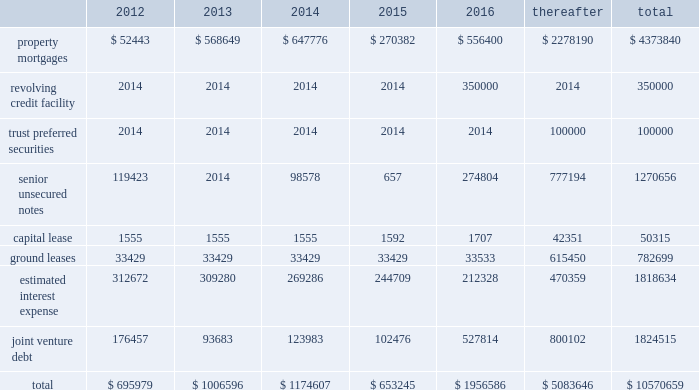56 / 57 management 2019s discussion and analysis of financial condition and results of operations junior subordinate deferrable interest debentures in june 2005 , we issued $ 100.0 a0million of trust preferred securities , which are reflected on the balance sheet as junior subordinate deferrable interest debentures .
The proceeds were used to repay our revolving credit facility .
The $ 100.0 a0million of junior subordi- nate deferrable interest debentures have a 30-year term ending july 2035 .
They bear interest at a fixed rate of 5.61% ( 5.61 % ) for the first 10 years ending july 2015 .
Thereafter , the rate will float at three month libor plus 1.25% ( 1.25 % ) .
The securities are redeemable at par .
Restrictive covenants the terms of the 2011 revolving credit facility and certain of our senior unsecured notes include certain restrictions and covenants which may limit , among other things , our ability to pay dividends ( as discussed below ) , make certain types of investments , incur additional indebtedness , incur liens and enter into negative pledge agreements and the disposition of assets , and which require compliance with financial ratios including our minimum tangible net worth , a maximum ratio of total indebtedness to total asset value , a minimum ratio of ebitda to fixed charges and a maximum ratio of unsecured indebtedness to unencumbered asset value .
The dividend restriction referred to above provides that we will not during any time when we are in default , make distributions with respect to common stock or other equity interests , except to enable us to continue to qualify as a reit for federal income tax purposes .
As of december a031 , 2011 and 2010 , we were in compli- ance with all such covenants .
Market rate risk we are exposed to changes in interest rates primarily from our floating rate borrowing arrangements .
We use interest rate deriv- ative instruments to manage exposure to interest rate changes .
A a0hypothetical 100 a0basis point increase in interest rates along the entire interest rate curve for 2011 and 2010 , would increase our annual interest cost by approximately $ 12.3 a0million and $ 11.0 a0mil- lion and would increase our share of joint venture annual interest cost by approximately $ 4.8 a0million and $ 6.7 a0million , respectively .
We recognize all derivatives on the balance sheet at fair value .
Derivatives that are not hedges must be adjusted to fair value through income .
If a derivative is a hedge , depending on the nature of the hedge , changes in the fair value of the derivative will either be offset against the change in fair value of the hedged asset , liability , or firm commitment through earnings , or recognized in other comprehensive income until the hedged item is recognized in earnings .
The ineffective portion of a derivative 2019s change in fair value is recognized immediately in earnings .
Approximately $ 4.8 a0billion of our long- term debt bore interest a0at fixed rates , and therefore the fair value of these instru- ments is affected by changes in the market interest rates .
The interest rate on our variable rate debt and joint venture debt as of december a031 , 2011 ranged from libor plus 150 a0basis points to libor plus 350 a0basis points .
Contractual obligations combined aggregate principal maturities of mortgages and other loans payable , our 2011 revolving credit facility , senior unsecured notes ( net of discount ) , trust preferred securities , our share of joint venture debt , including as- of-right extension options , estimated interest expense ( based on weighted average interest rates for the quarter ) , and our obligations under our capital lease and ground leases , as of december a031 , 2011 are as follows ( in thousands ) : .

What percentage of total obligations is the property mortgages and ground leases obligations? 
Computations: (4373840 + 782699)
Answer: 5156539.0. 